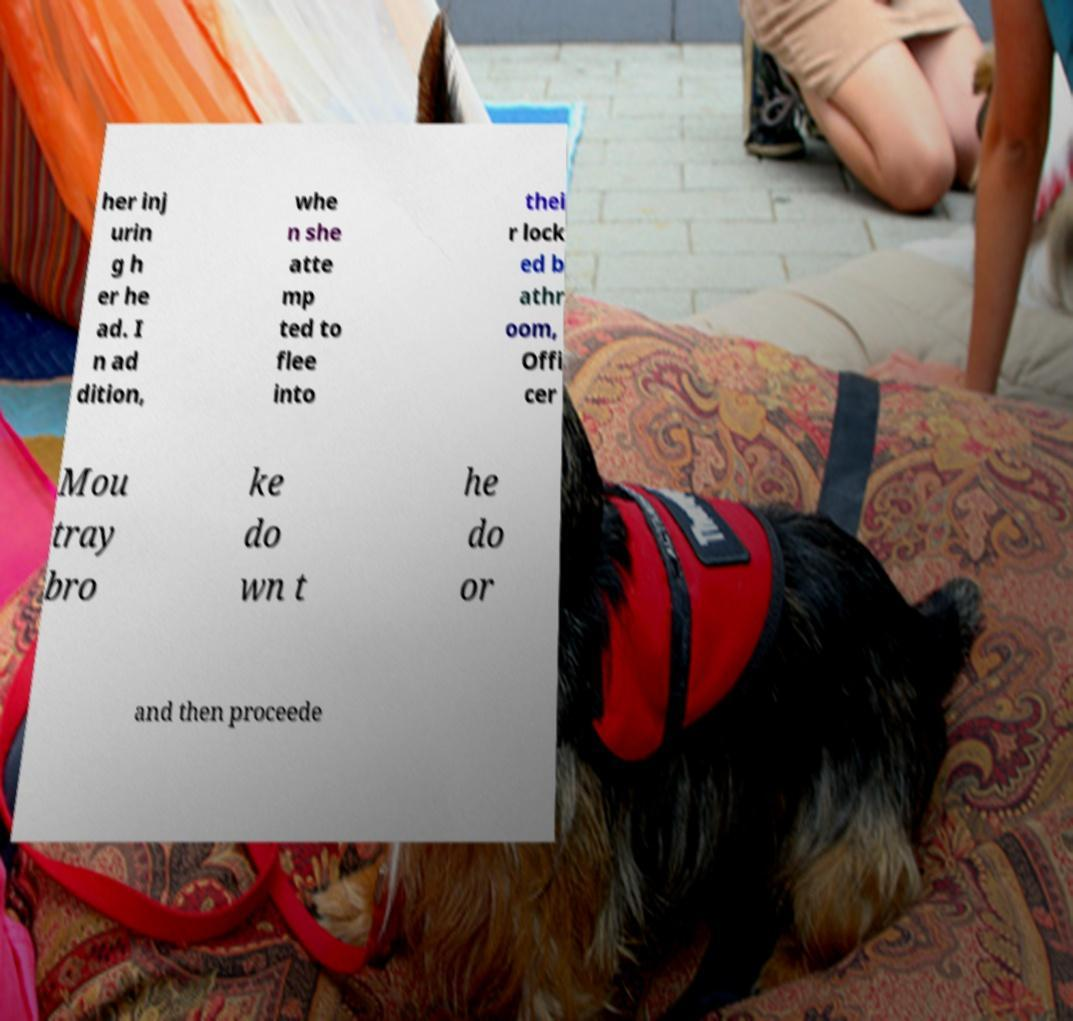I need the written content from this picture converted into text. Can you do that? her inj urin g h er he ad. I n ad dition, whe n she atte mp ted to flee into thei r lock ed b athr oom, Offi cer Mou tray bro ke do wn t he do or and then proceede 